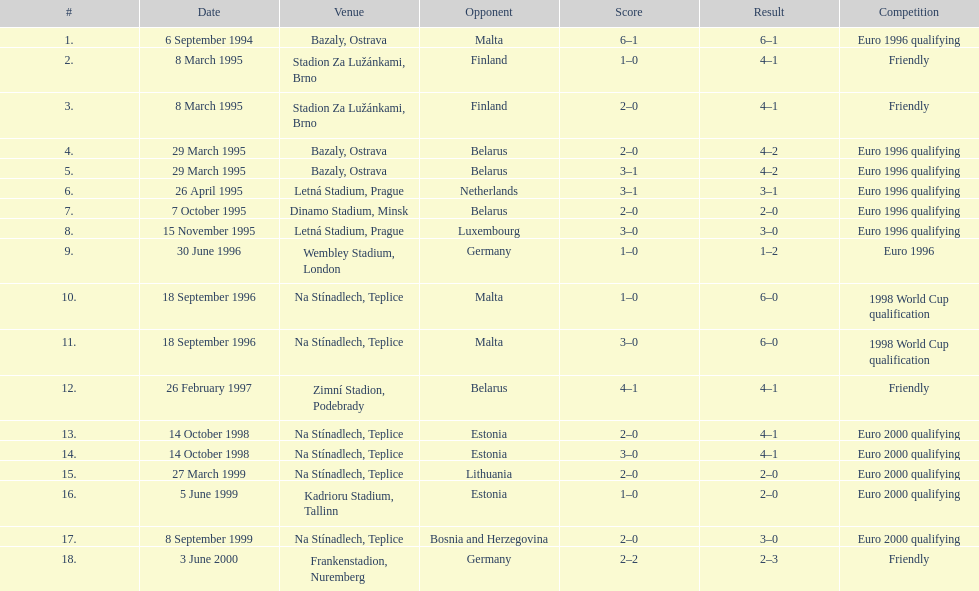How many times have the czech republic and germany faced each other in matches? 2. 